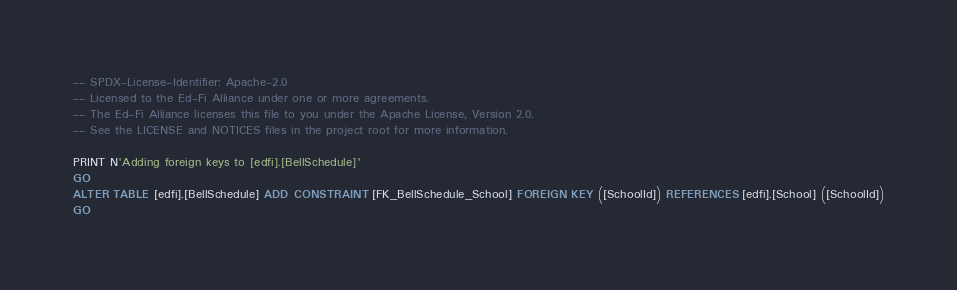<code> <loc_0><loc_0><loc_500><loc_500><_SQL_>-- SPDX-License-Identifier: Apache-2.0
-- Licensed to the Ed-Fi Alliance under one or more agreements.
-- The Ed-Fi Alliance licenses this file to you under the Apache License, Version 2.0.
-- See the LICENSE and NOTICES files in the project root for more information.

PRINT N'Adding foreign keys to [edfi].[BellSchedule]'
GO
ALTER TABLE [edfi].[BellSchedule] ADD CONSTRAINT [FK_BellSchedule_School] FOREIGN KEY ([SchoolId]) REFERENCES [edfi].[School] ([SchoolId])
GO
</code> 